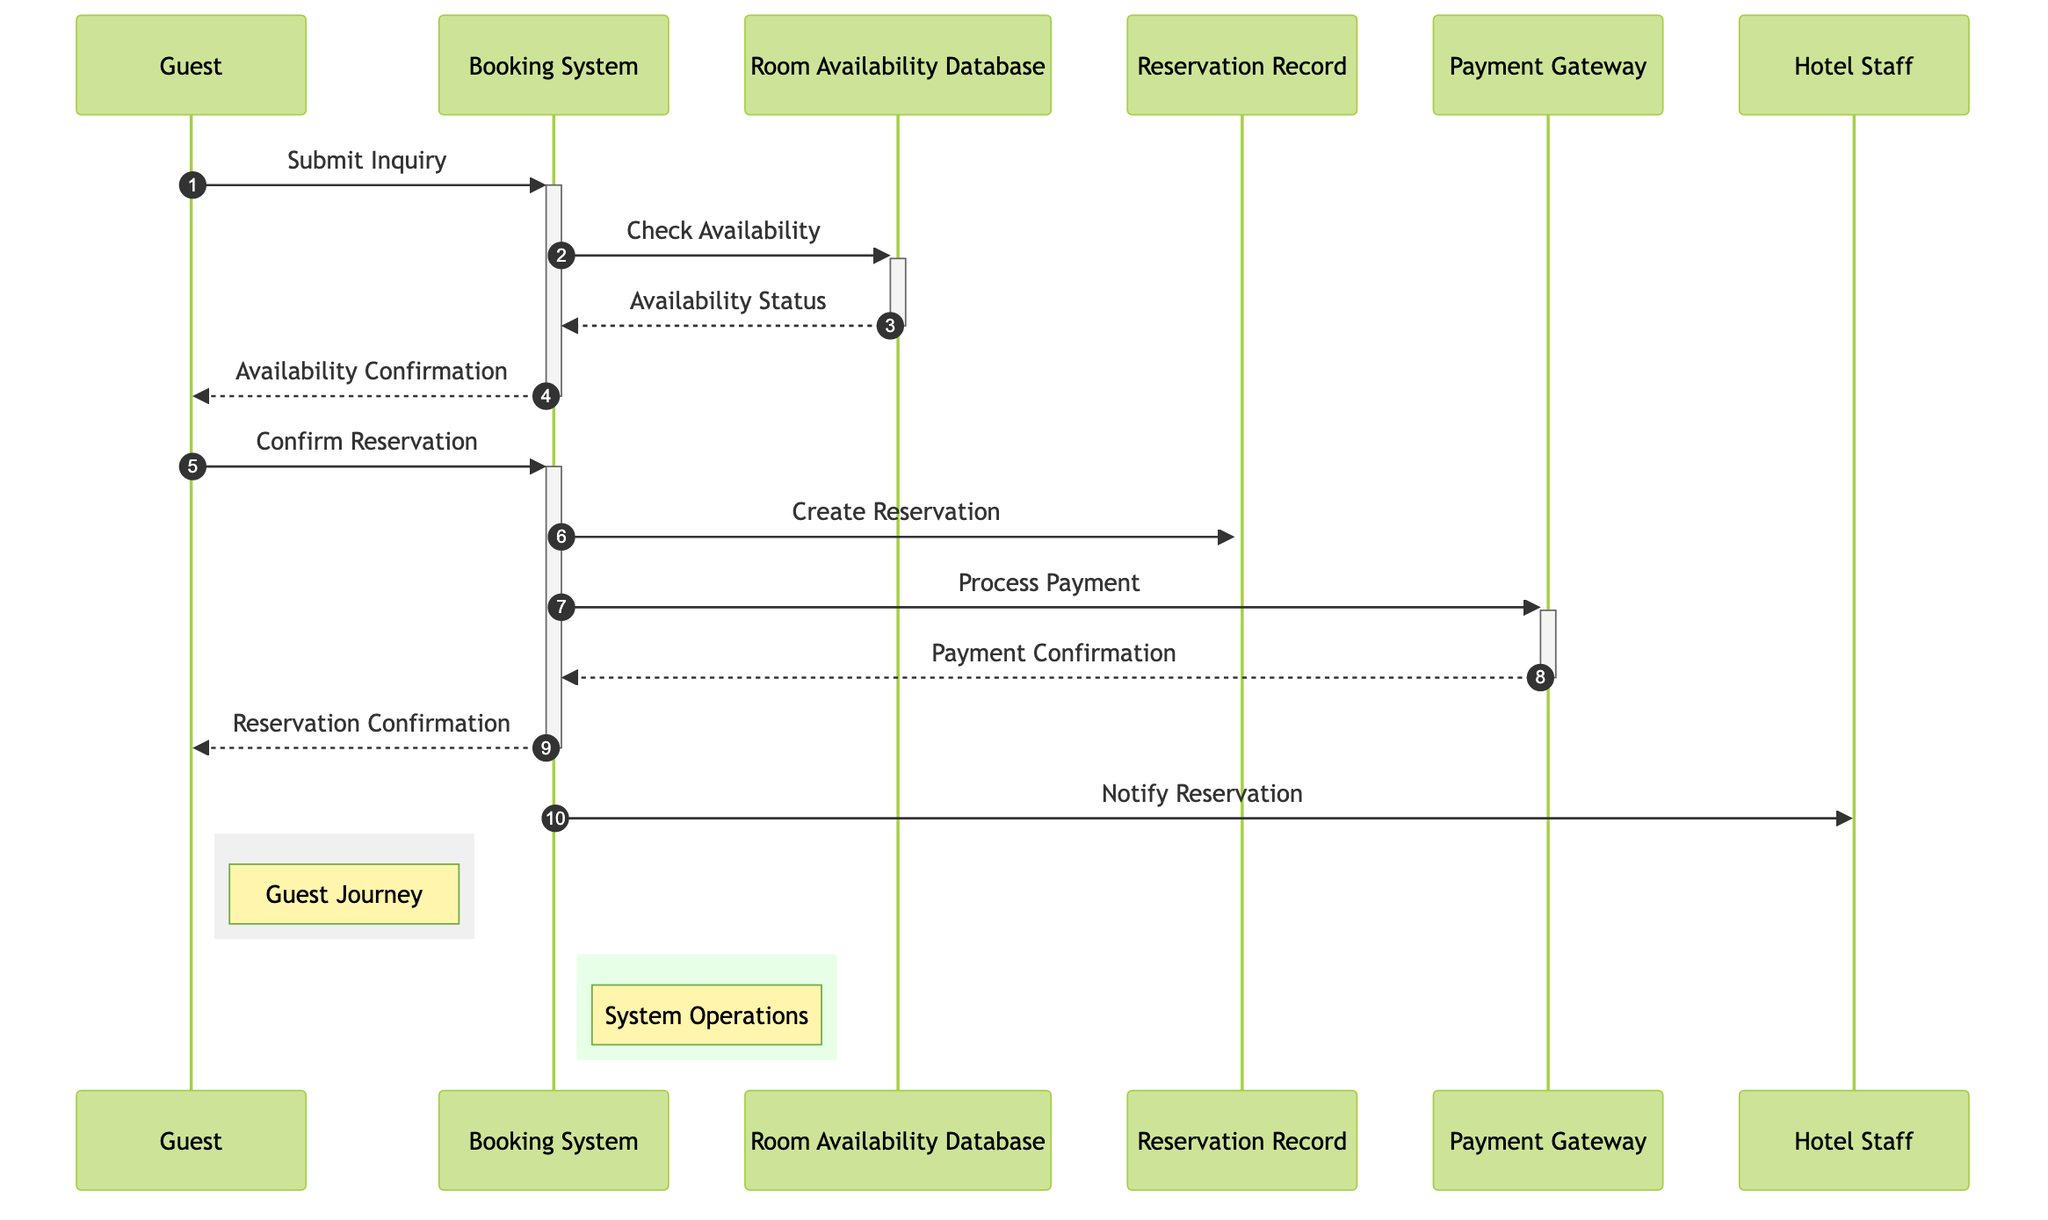What actors are involved in the diagram? The actors are listed at the start of the diagram, which includes the Guest, Booking System, Hotel Staff, and Payment Gateway.
Answer: Guest, Booking System, Hotel Staff, Payment Gateway How many messages are exchanged in total? Counting the messages in the diagram, there are ten interactions listed between the actors and objects, indicating the total number of messages exchanged.
Answer: Ten What does the Guest submit initially? The first message in the sequence indicates that the Guest submits an Inquiry to the Booking System.
Answer: Inquiry Which object does the Booking System check for availability? Looking at the message flow, the Booking System queries the Room Availability Database to check for room availability.
Answer: Room Availability Database What does the Booking System create after the Guest confirms the reservation? After receiving confirmation from the Guest, the Booking System creates a Reservation Record to finalize the booking process.
Answer: Reservation What is the final confirmation message sent to the Guest? The last interaction before notifying Hotel Staff is where the Booking System sends a Reservation Confirmation to the Guest.
Answer: Reservation Confirmation What happens before the Reservation Confirmation is sent to the Guest? Before the Reservation Confirmation is sent, the Booking System needs to have received a Payment Confirmation from the Payment Gateway after processing the payment.
Answer: Payment Confirmation Which system operation does the Booking System perform at the beginning? The first operation performed by the Booking System upon receiving the inquiry from the Guest is checking the availability in the Room Availability Database.
Answer: Check Availability What notification does the Booking System send to the Hotel Staff? At the end of the process, the Booking System sends a notification regarding the reservation to the Hotel Staff.
Answer: Notify Reservation 